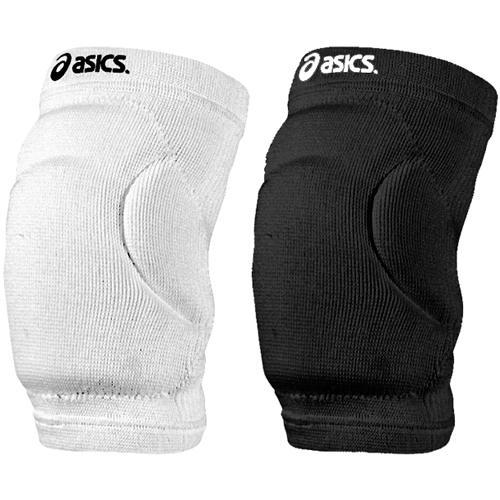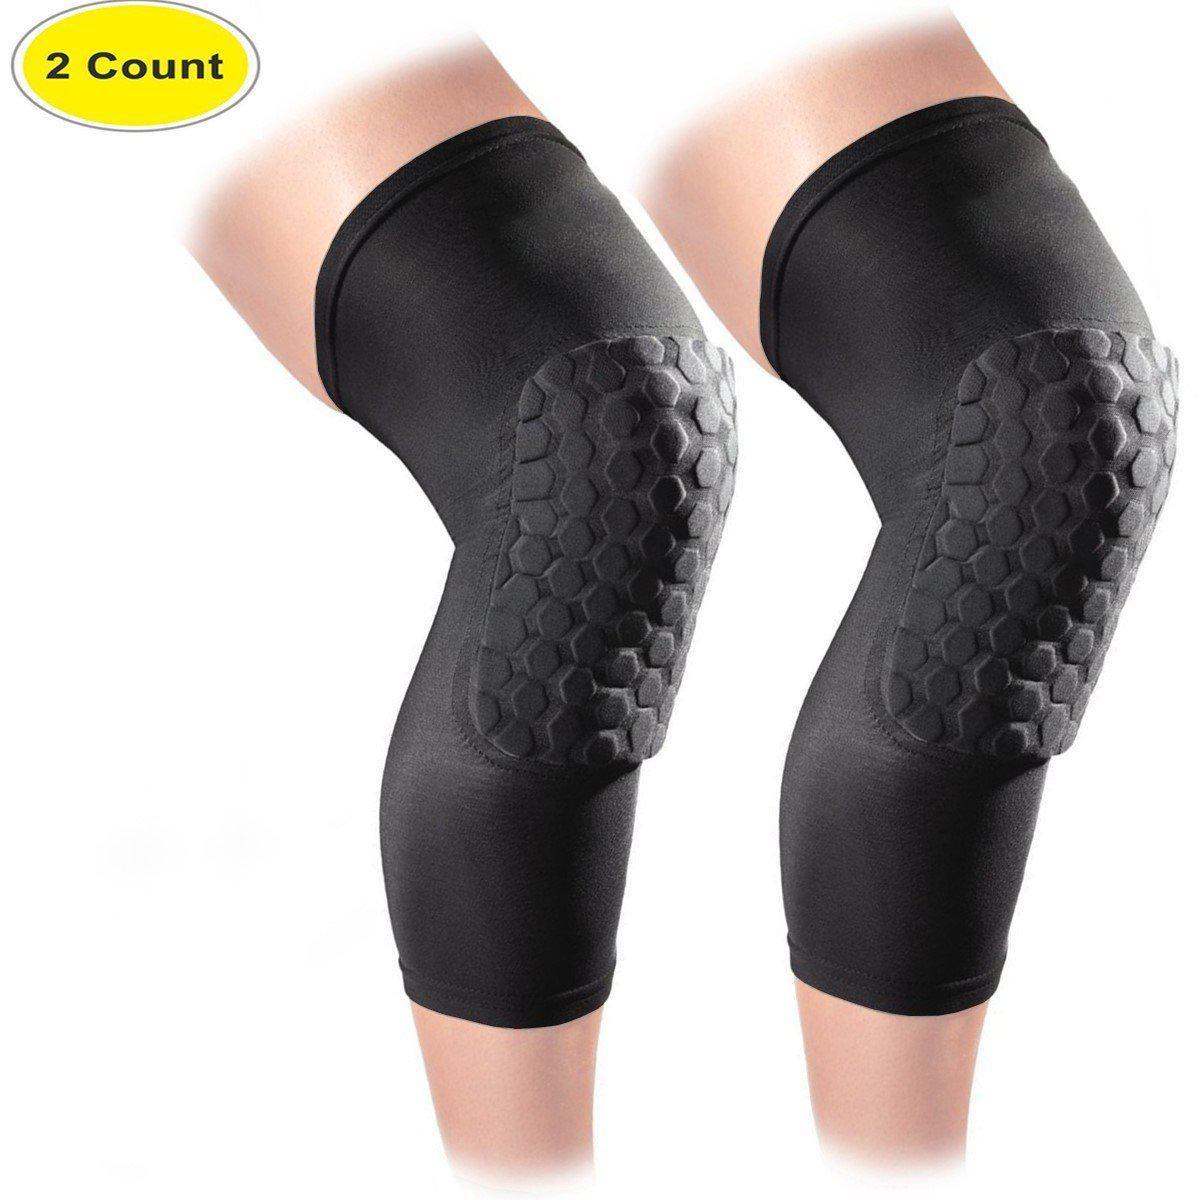The first image is the image on the left, the second image is the image on the right. Given the left and right images, does the statement "One image shows one each of white and black knee pads." hold true? Answer yes or no. Yes. The first image is the image on the left, the second image is the image on the right. Considering the images on both sides, is "There are three black knee braces and one white knee brace." valid? Answer yes or no. Yes. The first image is the image on the left, the second image is the image on the right. Considering the images on both sides, is "Three of the four total knee pads are black" valid? Answer yes or no. Yes. The first image is the image on the left, the second image is the image on the right. Given the left and right images, does the statement "At least one pair of kneepads is worn by a human." hold true? Answer yes or no. Yes. 